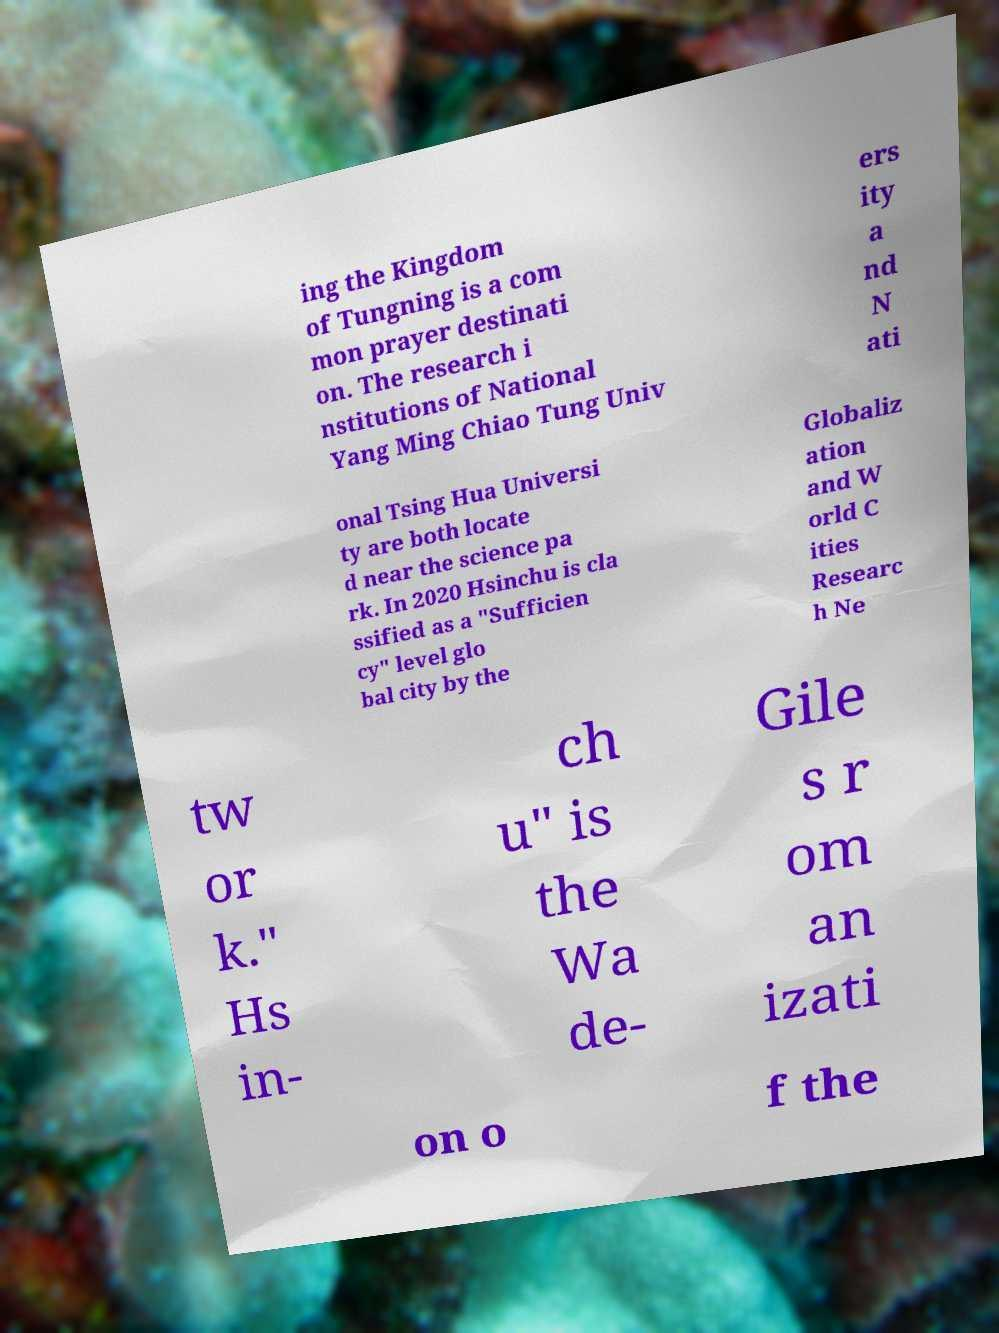There's text embedded in this image that I need extracted. Can you transcribe it verbatim? ing the Kingdom of Tungning is a com mon prayer destinati on. The research i nstitutions of National Yang Ming Chiao Tung Univ ers ity a nd N ati onal Tsing Hua Universi ty are both locate d near the science pa rk. In 2020 Hsinchu is cla ssified as a "Sufficien cy" level glo bal city by the Globaliz ation and W orld C ities Researc h Ne tw or k." Hs in- ch u" is the Wa de- Gile s r om an izati on o f the 